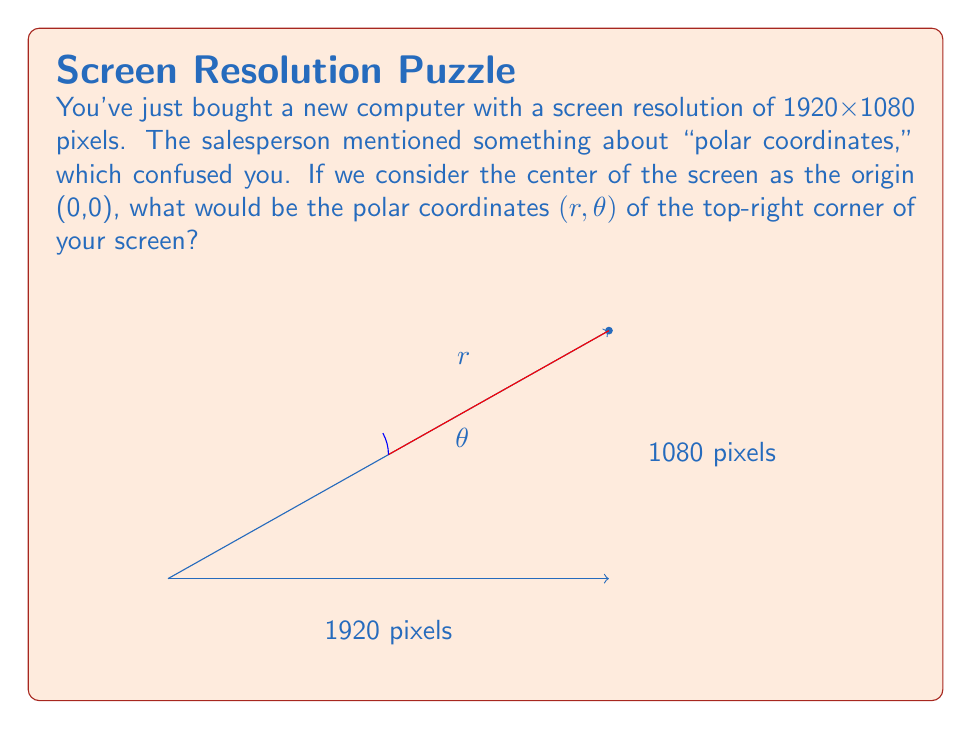Help me with this question. Let's approach this step-by-step:

1) In rectangular coordinates, the top-right corner is at (960, 540), as half of 1920 is 960 and half of 1080 is 540.

2) To convert from rectangular (x, y) to polar (r, θ) coordinates, we use these formulas:

   $r = \sqrt{x^2 + y^2}$
   $\theta = \arctan(\frac{y}{x})$

3) Let's calculate r first:
   $$r = \sqrt{960^2 + 540^2} = \sqrt{921600 + 291600} = \sqrt{1213200} \approx 1101.45$$

4) Now for θ:
   $$\theta = \arctan(\frac{540}{960}) \approx 0.5104 \text{ radians}$$

5) We often express θ in degrees for easier understanding. To convert:
   $$0.5104 \text{ radians} \times \frac{180°}{\pi} \approx 29.25°$$

Therefore, the polar coordinates of the top-right corner are approximately (1101.45, 29.25°).
Answer: (1101.45, 29.25°) 